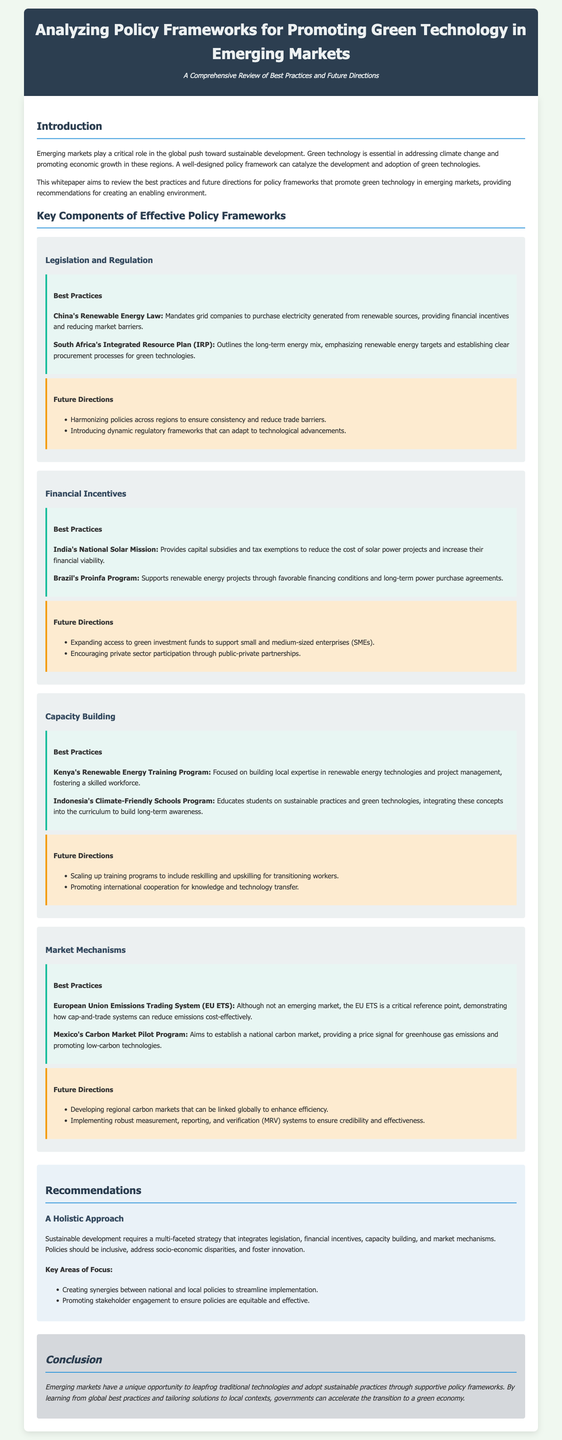What are the key components of effective policy frameworks? The document outlines key components such as legislation and regulation, financial incentives, capacity building, and market mechanisms.
Answer: Legislation and regulation, financial incentives, capacity building, market mechanisms What is one of the best practices for legislation in China? The document states that China's Renewable Energy Law mandates grid companies to purchase electricity generated from renewable sources.
Answer: Mandates grid companies to purchase electricity generated from renewable sources What financial incentive is provided by India's National Solar Mission? The white paper mentions that the National Solar Mission provides capital subsidies and tax exemptions to reduce costs.
Answer: Capital subsidies and tax exemptions What is a future direction for capacity building? The document suggests a future direction of scaling up training programs for reskilling and upskilling transitioning workers.
Answer: Scaling up training programs for reskilling and upskilling What is a recommendation for promoting stakeholder engagement? The white paper recommends promoting stakeholder engagement to ensure policies are equitable and effective.
Answer: Promoting stakeholder engagement What does the conclusion suggest about emerging markets? The conclusion highlights that emerging markets can adopt sustainable practices through supportive policy frameworks.
Answer: Adopt sustainable practices through supportive policy frameworks What is a best practice in market mechanisms noted in Mexico? The document mentions Mexico's Carbon Market Pilot Program aims to establish a national carbon market.
Answer: Aims to establish a national carbon market What should policies focus on according to the recommendations section? The recommendations section indicates that policies should focus on a multi-faceted strategy integrating multiple elements.
Answer: A multi-faceted strategy integrating legislation, financial incentives, capacity building, and market mechanisms 